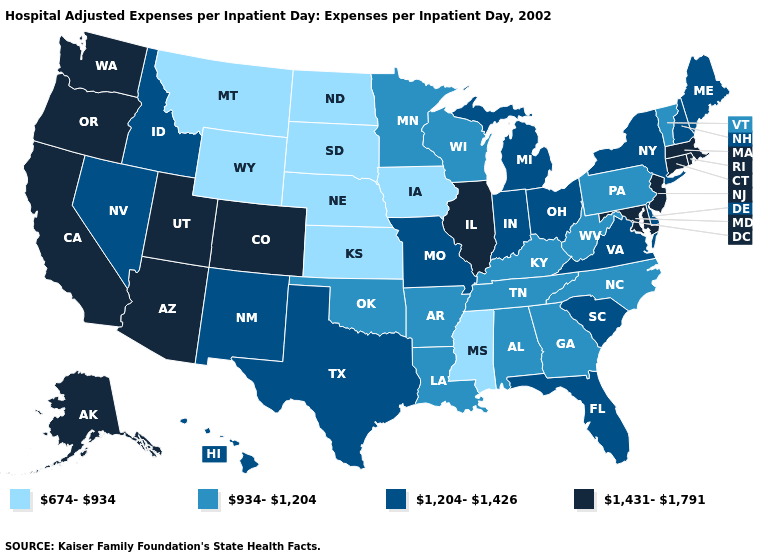Name the states that have a value in the range 934-1,204?
Give a very brief answer. Alabama, Arkansas, Georgia, Kentucky, Louisiana, Minnesota, North Carolina, Oklahoma, Pennsylvania, Tennessee, Vermont, West Virginia, Wisconsin. Among the states that border California , does Nevada have the lowest value?
Quick response, please. Yes. Does Missouri have a lower value than Illinois?
Be succinct. Yes. Does Kentucky have the lowest value in the USA?
Concise answer only. No. What is the value of Kansas?
Give a very brief answer. 674-934. What is the value of New York?
Concise answer only. 1,204-1,426. Is the legend a continuous bar?
Quick response, please. No. Name the states that have a value in the range 1,204-1,426?
Keep it brief. Delaware, Florida, Hawaii, Idaho, Indiana, Maine, Michigan, Missouri, Nevada, New Hampshire, New Mexico, New York, Ohio, South Carolina, Texas, Virginia. What is the highest value in the USA?
Concise answer only. 1,431-1,791. Does the map have missing data?
Quick response, please. No. Does the first symbol in the legend represent the smallest category?
Short answer required. Yes. What is the highest value in states that border Washington?
Short answer required. 1,431-1,791. Name the states that have a value in the range 674-934?
Quick response, please. Iowa, Kansas, Mississippi, Montana, Nebraska, North Dakota, South Dakota, Wyoming. What is the value of New Mexico?
Keep it brief. 1,204-1,426. What is the lowest value in states that border Minnesota?
Write a very short answer. 674-934. 